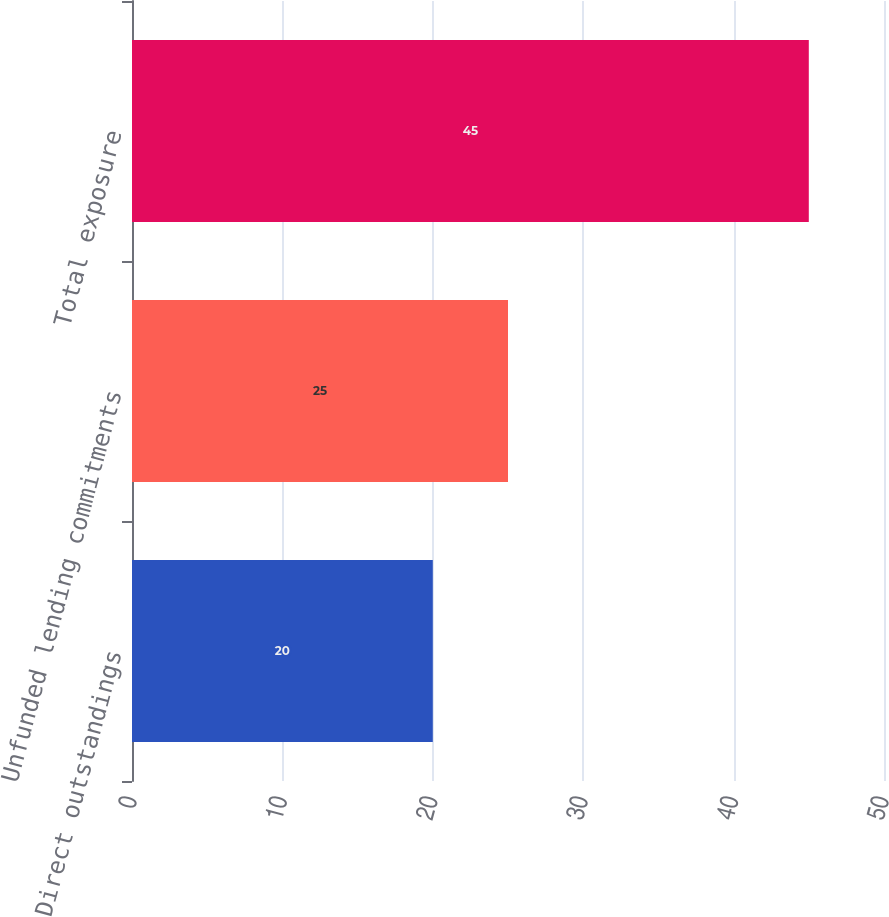Convert chart. <chart><loc_0><loc_0><loc_500><loc_500><bar_chart><fcel>Direct outstandings<fcel>Unfunded lending commitments<fcel>Total exposure<nl><fcel>20<fcel>25<fcel>45<nl></chart> 